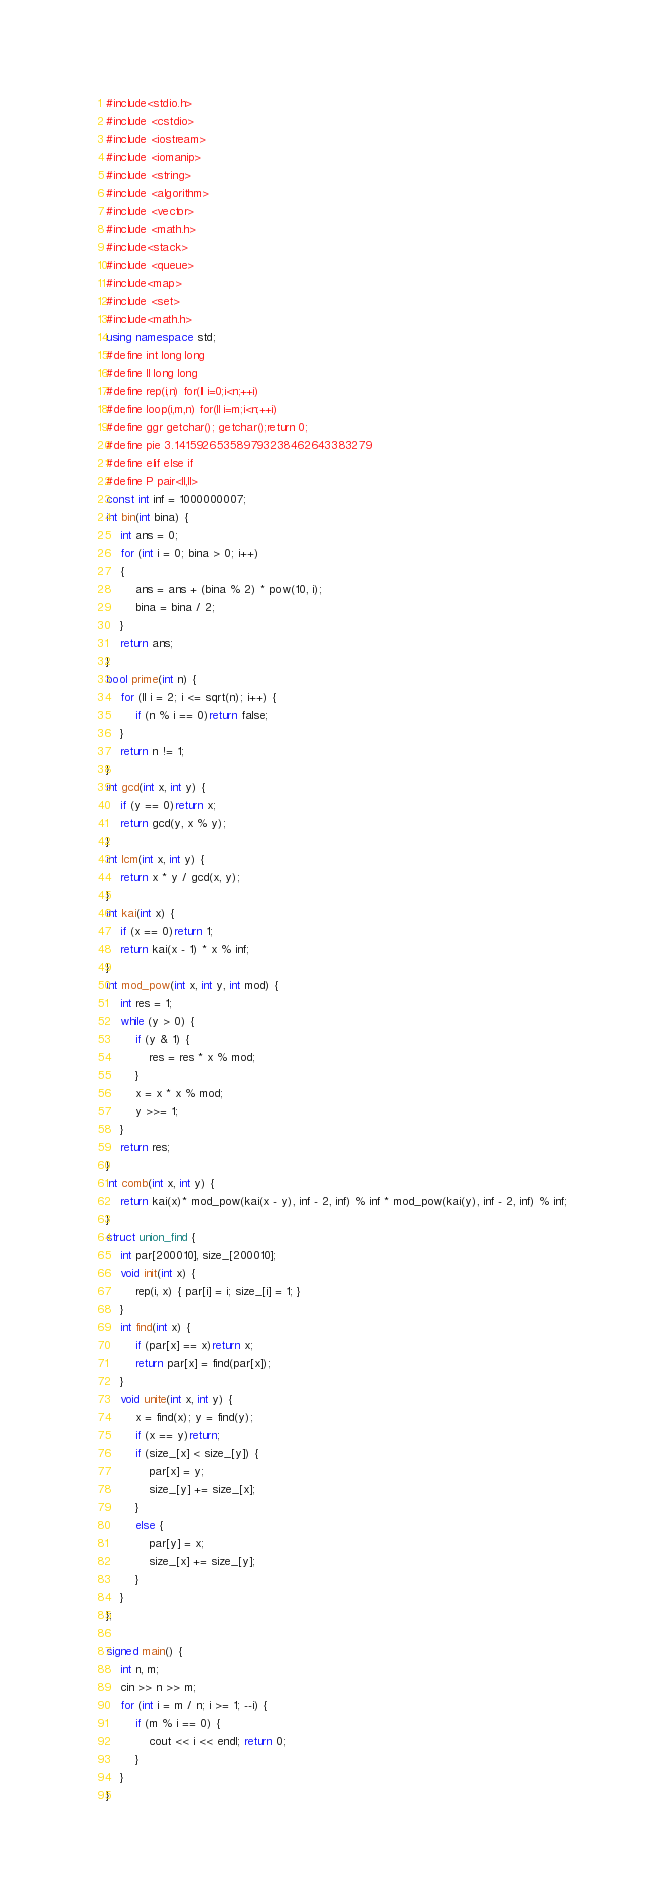Convert code to text. <code><loc_0><loc_0><loc_500><loc_500><_C++_>#include<stdio.h>
#include <cstdio>
#include <iostream>
#include <iomanip>
#include <string>
#include <algorithm>
#include <vector>
#include <math.h>
#include<stack>
#include <queue>
#include<map>
#include <set>
#include<math.h>
using namespace std;
#define int long long
#define ll long long
#define rep(i,n) for(ll i=0;i<n;++i)
#define loop(i,m,n) for(ll i=m;i<n;++i)
#define ggr getchar(); getchar();return 0;
#define pie 3.141592653589793238462643383279
#define elif else if
#define P pair<ll,ll>
const int inf = 1000000007;
int bin(int bina) {
	int ans = 0;
	for (int i = 0; bina > 0; i++)
	{
		ans = ans + (bina % 2) * pow(10, i);
		bina = bina / 2;
	}
	return ans;
}
bool prime(int n) {
	for (ll i = 2; i <= sqrt(n); i++) {
		if (n % i == 0)return false;
	}
	return n != 1;
}
int gcd(int x, int y) {
	if (y == 0)return x;
	return gcd(y, x % y);
}
int lcm(int x, int y) {
	return x * y / gcd(x, y);
}
int kai(int x) {
	if (x == 0)return 1;
	return kai(x - 1) * x % inf;
}
int mod_pow(int x, int y, int mod) {
	int res = 1;
	while (y > 0) {
		if (y & 1) {
			res = res * x % mod;
		}
		x = x * x % mod;
		y >>= 1;
	}
	return res;
}
int comb(int x, int y) {
	return kai(x)* mod_pow(kai(x - y), inf - 2, inf) % inf * mod_pow(kai(y), inf - 2, inf) % inf;
}
struct union_find {
	int par[200010], size_[200010];
	void init(int x) {
		rep(i, x) { par[i] = i; size_[i] = 1; }
	}
	int find(int x) {
		if (par[x] == x)return x;
		return par[x] = find(par[x]);
	}
	void unite(int x, int y) {
		x = find(x); y = find(y);
		if (x == y)return;
		if (size_[x] < size_[y]) {
			par[x] = y;
			size_[y] += size_[x];
		}
		else {
			par[y] = x;
			size_[x] += size_[y];
		}
	}
};

signed main() {	
	int n, m;
	cin >> n >> m;
	for (int i = m / n; i >= 1; --i) {
		if (m % i == 0) {
			cout << i << endl; return 0;
		}
	}
}</code> 